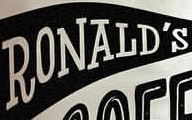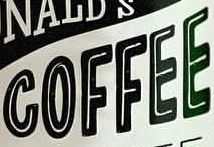Read the text content from these images in order, separated by a semicolon. RONALD'S; COFFEE 